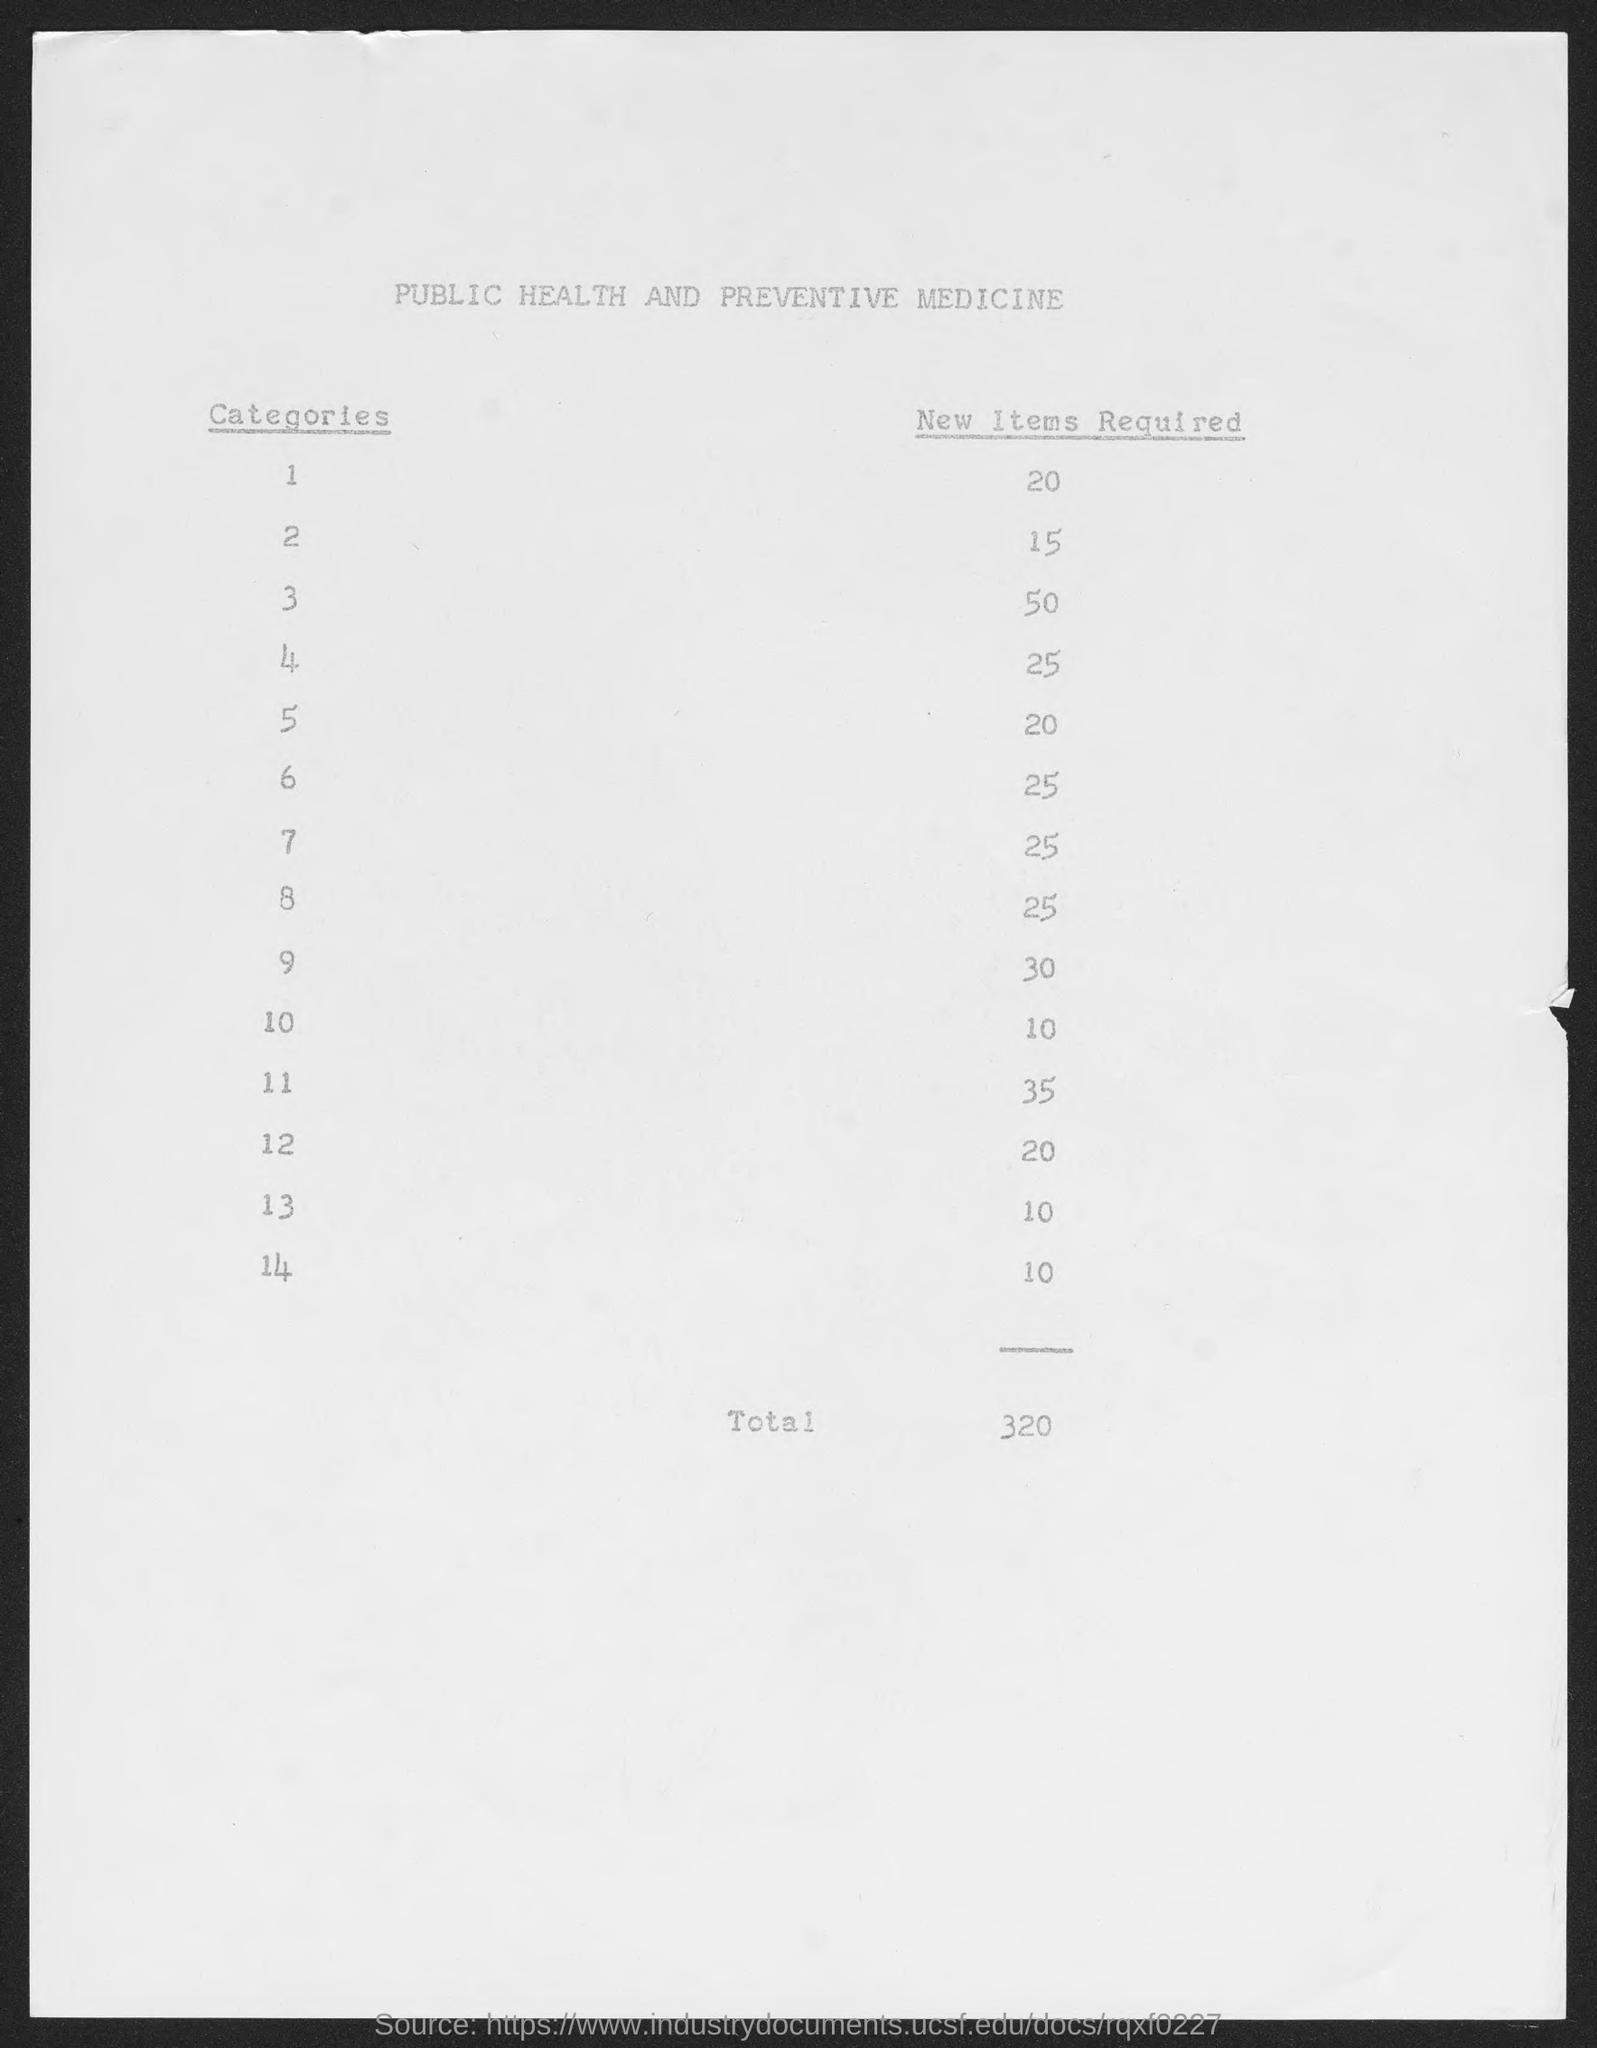Indicate a few pertinent items in this graphic. A total of 320 new items are required. The document is titled "Public Health and Preventive Medicine. There are 14 categories. 